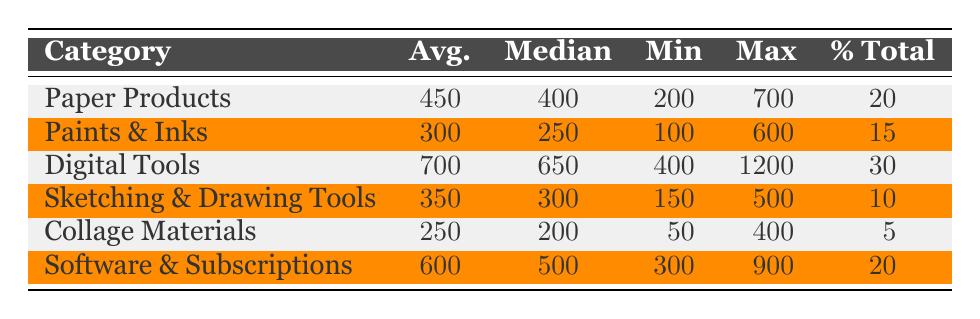What is the average expenditure on Digital Tools? From the table, we can see that the average expenditure for Digital Tools is listed in the corresponding row, which is 700.
Answer: 700 Which category has the highest maximum expenditure? By looking at the Max Expenditure column, we identify that the category Digital Tools has the highest maximum expenditure of 1200.
Answer: Digital Tools What is the total percentage of expenditure for Paper Products and Paints & Inks combined? To find the total percentage, we add the percentages of Paper Products (20) and Paints & Inks (15): 20 + 15 = 35.
Answer: 35 Is the median expenditure for Collage Materials greater than the median expenditure for Sketching & Drawing Tools? The median expenditure for Collage Materials is 200 and for Sketching & Drawing Tools is 300. Since 200 is less than 300, the statement is false.
Answer: No What is the difference between the average expenditure on Software & Subscriptions and Collage Materials? The average expenditure for Software & Subscriptions is 600 and for Collage Materials, it is 250. The difference is calculated as 600 - 250 = 350.
Answer: 350 How many categories have an average expenditure of 350 or more? Referring to the Average Expenditure column, the categories with average expenditures of 350 or more are Digital Tools (700), Paper Products (450), and Software & Subscriptions (600). Therefore, there are 3 categories.
Answer: 3 What is the lowest minimum expenditure recorded among the categories? By scanning the Min Expenditure column, we find that the lowest recorded minimum expenditure is 50 for Collage Materials.
Answer: 50 Is the average expenditure for Paints & Inks less than that of Sketching & Drawing Tools? The average for Paints & Inks is 300 and for Sketching & Drawing Tools is 350. Since 300 is less than 350, the answer to the question is yes.
Answer: Yes 